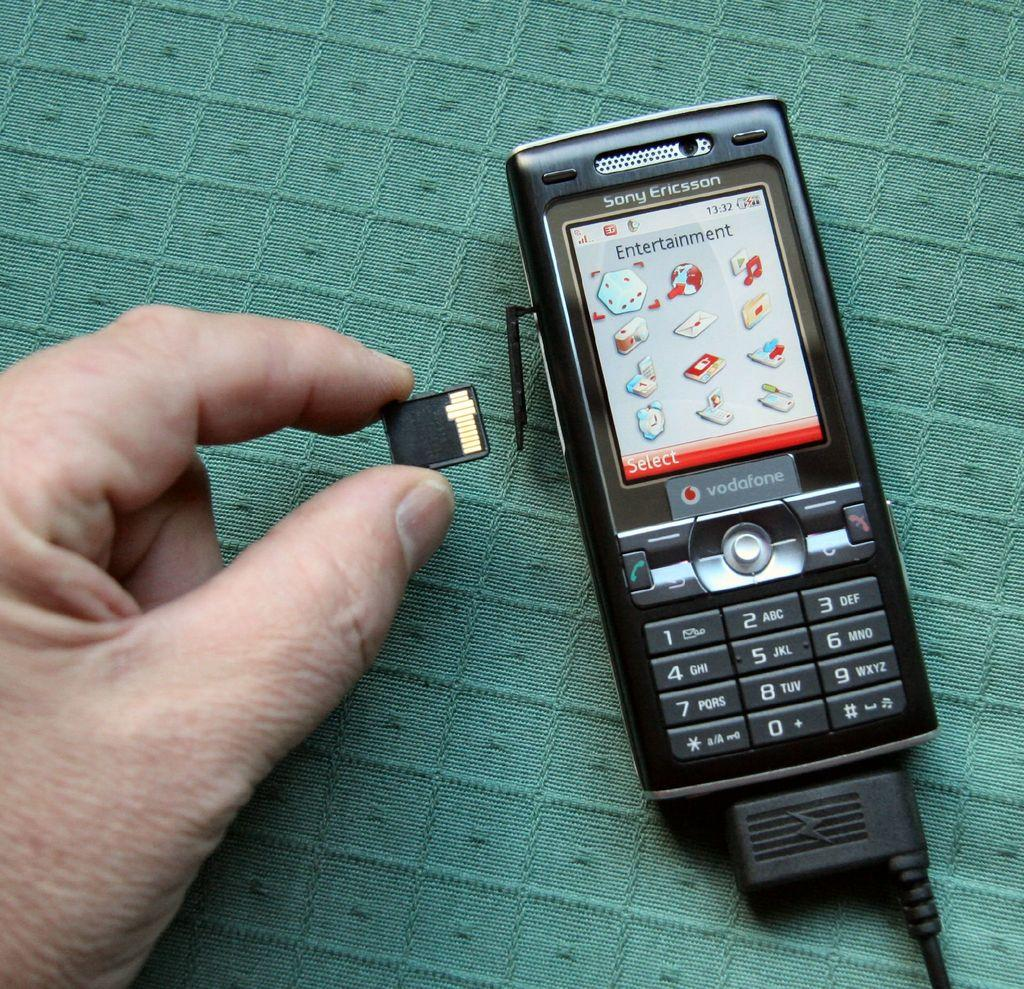<image>
Present a compact description of the photo's key features. the word vodafone is on the phone that is black 